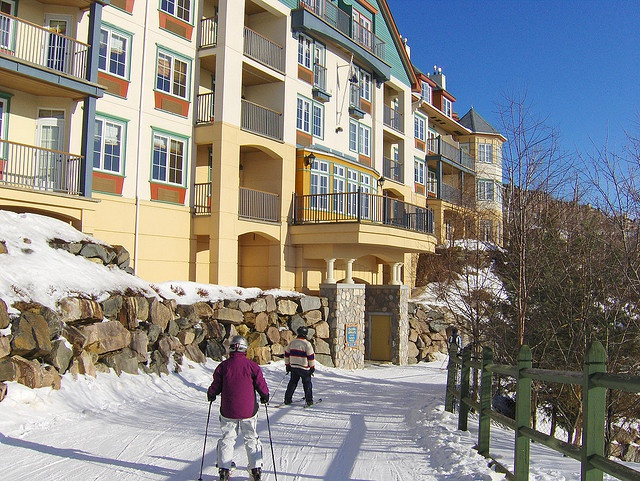Describe the objects in this image and their specific colors. I can see people in maroon, black, purple, lightgray, and darkgray tones, people in maroon, black, gray, and darkgray tones, people in maroon, black, navy, and gray tones, skis in maroon, gray, darkgray, lightgray, and black tones, and skis in maroon, gray, darkgray, and lightgray tones in this image. 